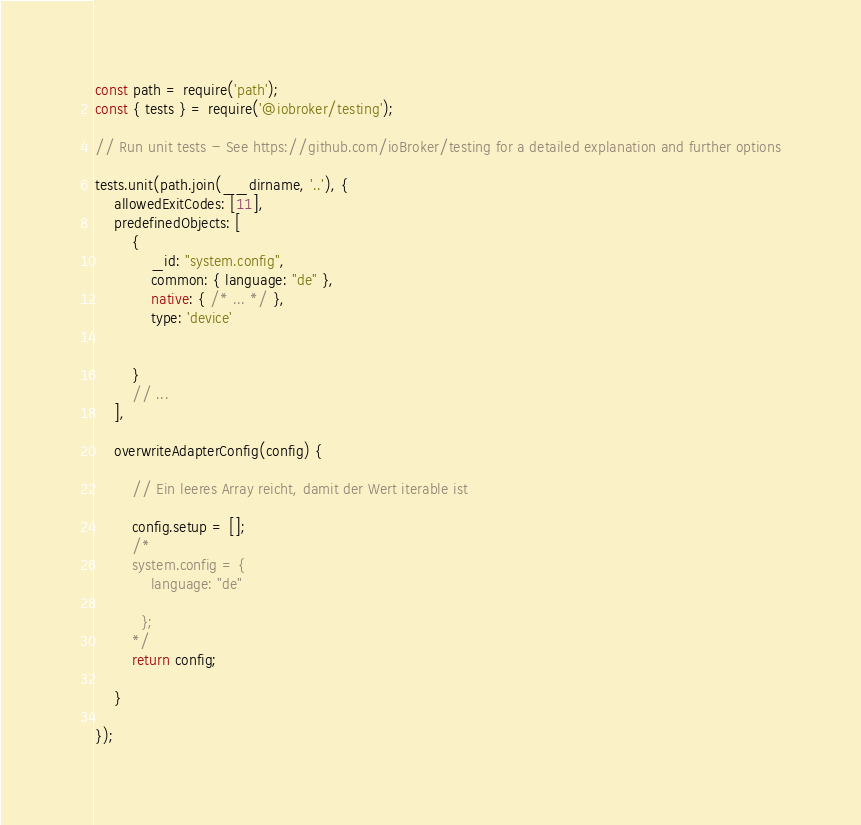Convert code to text. <code><loc_0><loc_0><loc_500><loc_500><_JavaScript_>const path = require('path');
const { tests } = require('@iobroker/testing');

// Run unit tests - See https://github.com/ioBroker/testing for a detailed explanation and further options

tests.unit(path.join(__dirname, '..'), {
    allowedExitCodes: [11],
    predefinedObjects: [
        {
            _id: "system.config",
            common: { language: "de" },
            native: { /* ... */ },
            type: 'device'

            
        }
        // ...
    ],

    overwriteAdapterConfig(config) {

        // Ein leeres Array reicht, damit der Wert iterable ist

        config.setup = [];
        /*
        system.config = {
            language: "de"
            
          };
        */
        return config;

    }

});</code> 